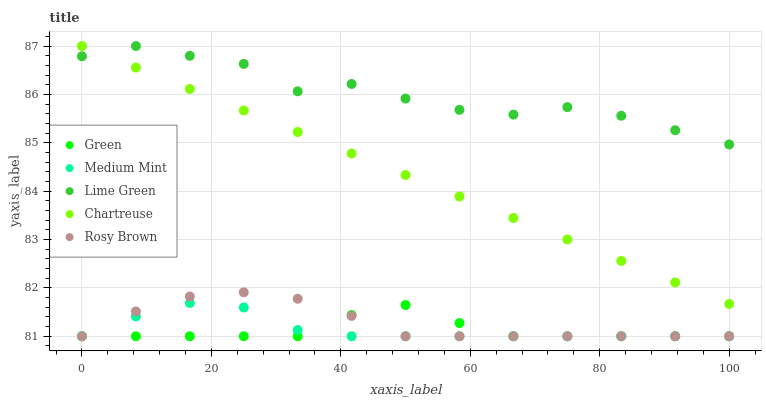Does Green have the minimum area under the curve?
Answer yes or no. Yes. Does Lime Green have the maximum area under the curve?
Answer yes or no. Yes. Does Chartreuse have the minimum area under the curve?
Answer yes or no. No. Does Chartreuse have the maximum area under the curve?
Answer yes or no. No. Is Chartreuse the smoothest?
Answer yes or no. Yes. Is Lime Green the roughest?
Answer yes or no. Yes. Is Lime Green the smoothest?
Answer yes or no. No. Is Chartreuse the roughest?
Answer yes or no. No. Does Medium Mint have the lowest value?
Answer yes or no. Yes. Does Chartreuse have the lowest value?
Answer yes or no. No. Does Chartreuse have the highest value?
Answer yes or no. Yes. Does Rosy Brown have the highest value?
Answer yes or no. No. Is Rosy Brown less than Lime Green?
Answer yes or no. Yes. Is Lime Green greater than Rosy Brown?
Answer yes or no. Yes. Does Rosy Brown intersect Medium Mint?
Answer yes or no. Yes. Is Rosy Brown less than Medium Mint?
Answer yes or no. No. Is Rosy Brown greater than Medium Mint?
Answer yes or no. No. Does Rosy Brown intersect Lime Green?
Answer yes or no. No. 